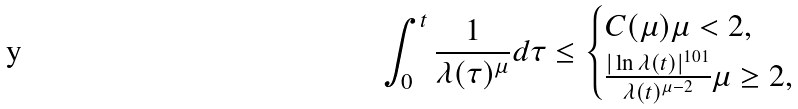<formula> <loc_0><loc_0><loc_500><loc_500>\int _ { 0 } ^ { t } \frac { 1 } { \lambda ( \tau ) ^ { \mu } } d \tau \leq \begin{cases} C ( \mu ) \mu < 2 , \\ \frac { | \ln \lambda ( t ) | ^ { 1 0 1 } } { \lambda ( t ) ^ { \mu - 2 } } \mu \geq 2 , \end{cases}</formula> 